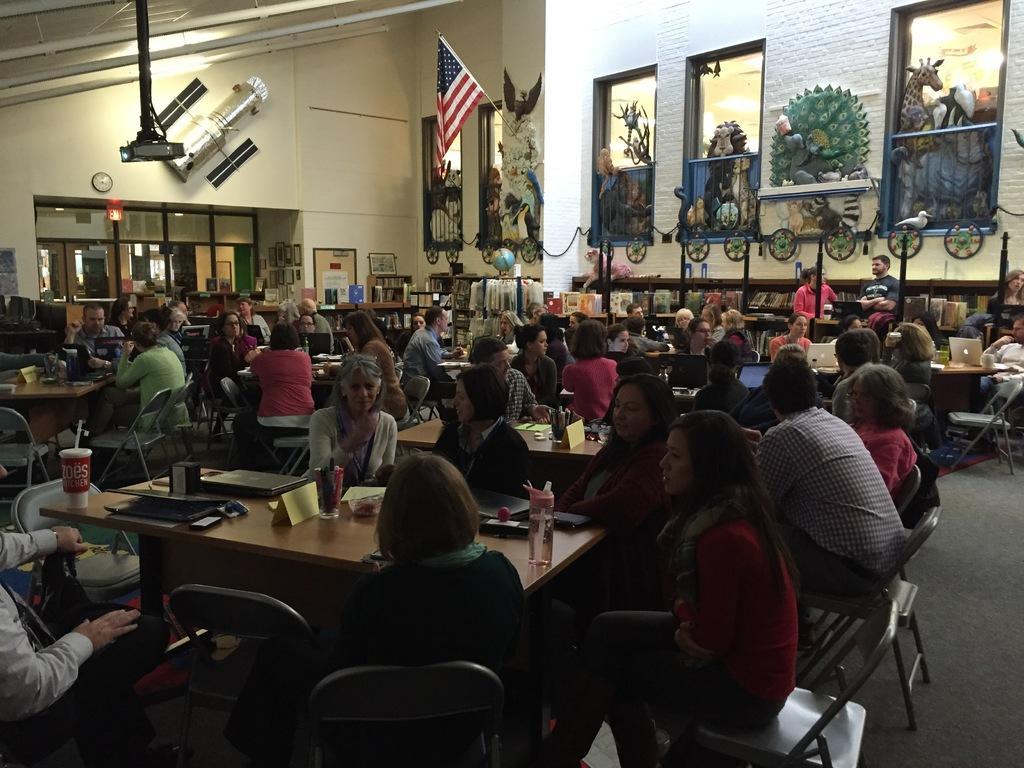Please provide a concise description of this image. This picture is clicked inside a room. There are many tables and chairs. People are sitting on chairs at the tables. On the tables there are bottles, laptops, pen holders, name boards and books. Behind the people there is a book rack and many books are placed in it. On one of the rock there is a globe. Behind the racks there is a board and next to it are photo frames hanging on wall. On the wall there are sculptures and a flag. There is also a projector hanging at the center of the room through the ceiling. On the wall there is clock and above it there is a tube light.  